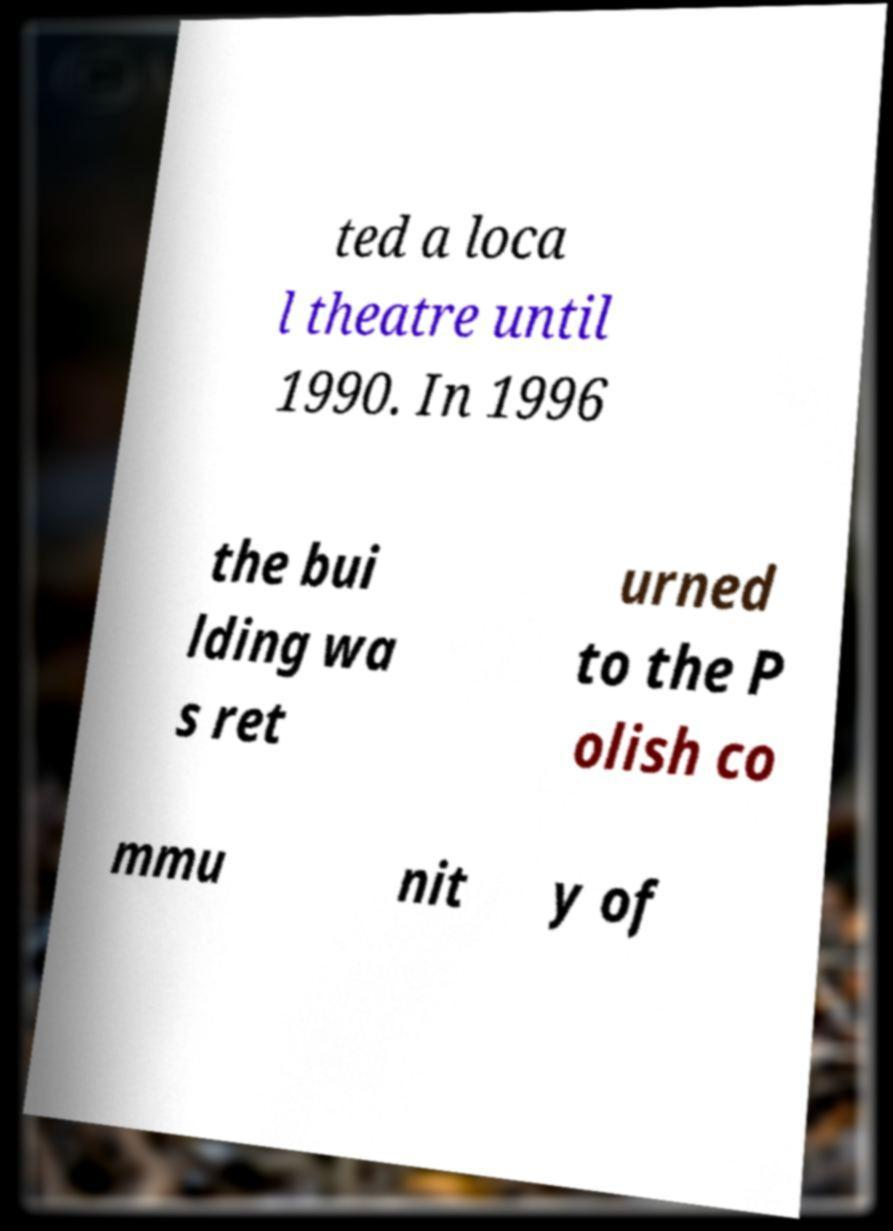What messages or text are displayed in this image? I need them in a readable, typed format. ted a loca l theatre until 1990. In 1996 the bui lding wa s ret urned to the P olish co mmu nit y of 